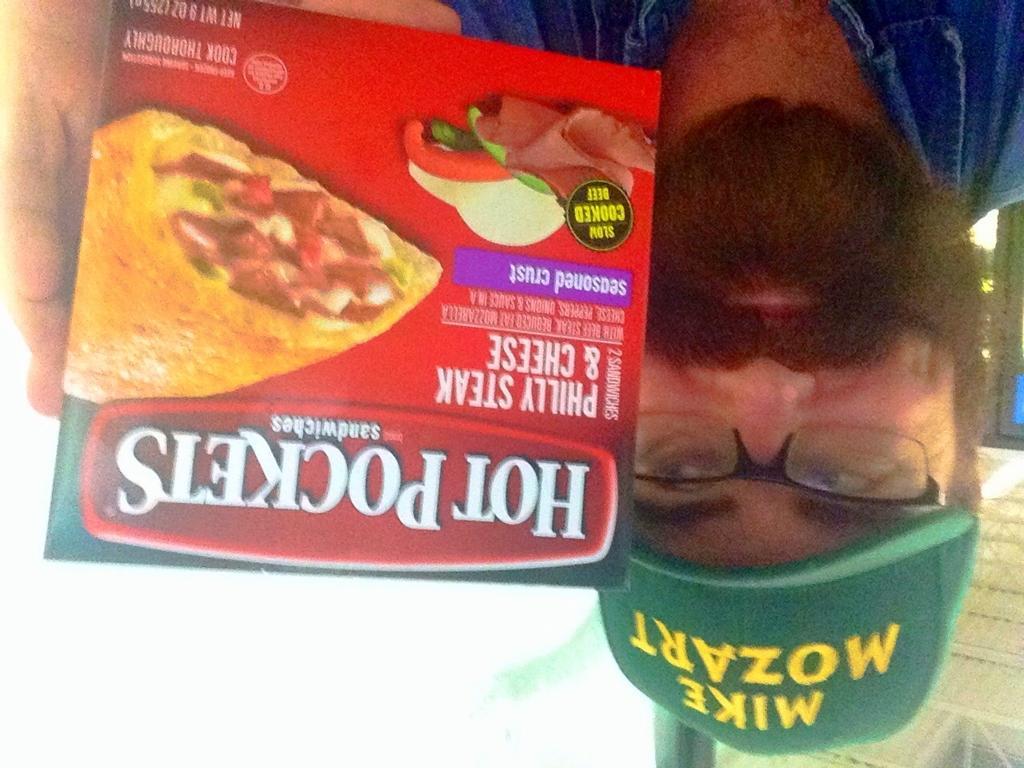Describe this image in one or two sentences. In this picture I can see a person holding the food box. And in the background there are some objects. 